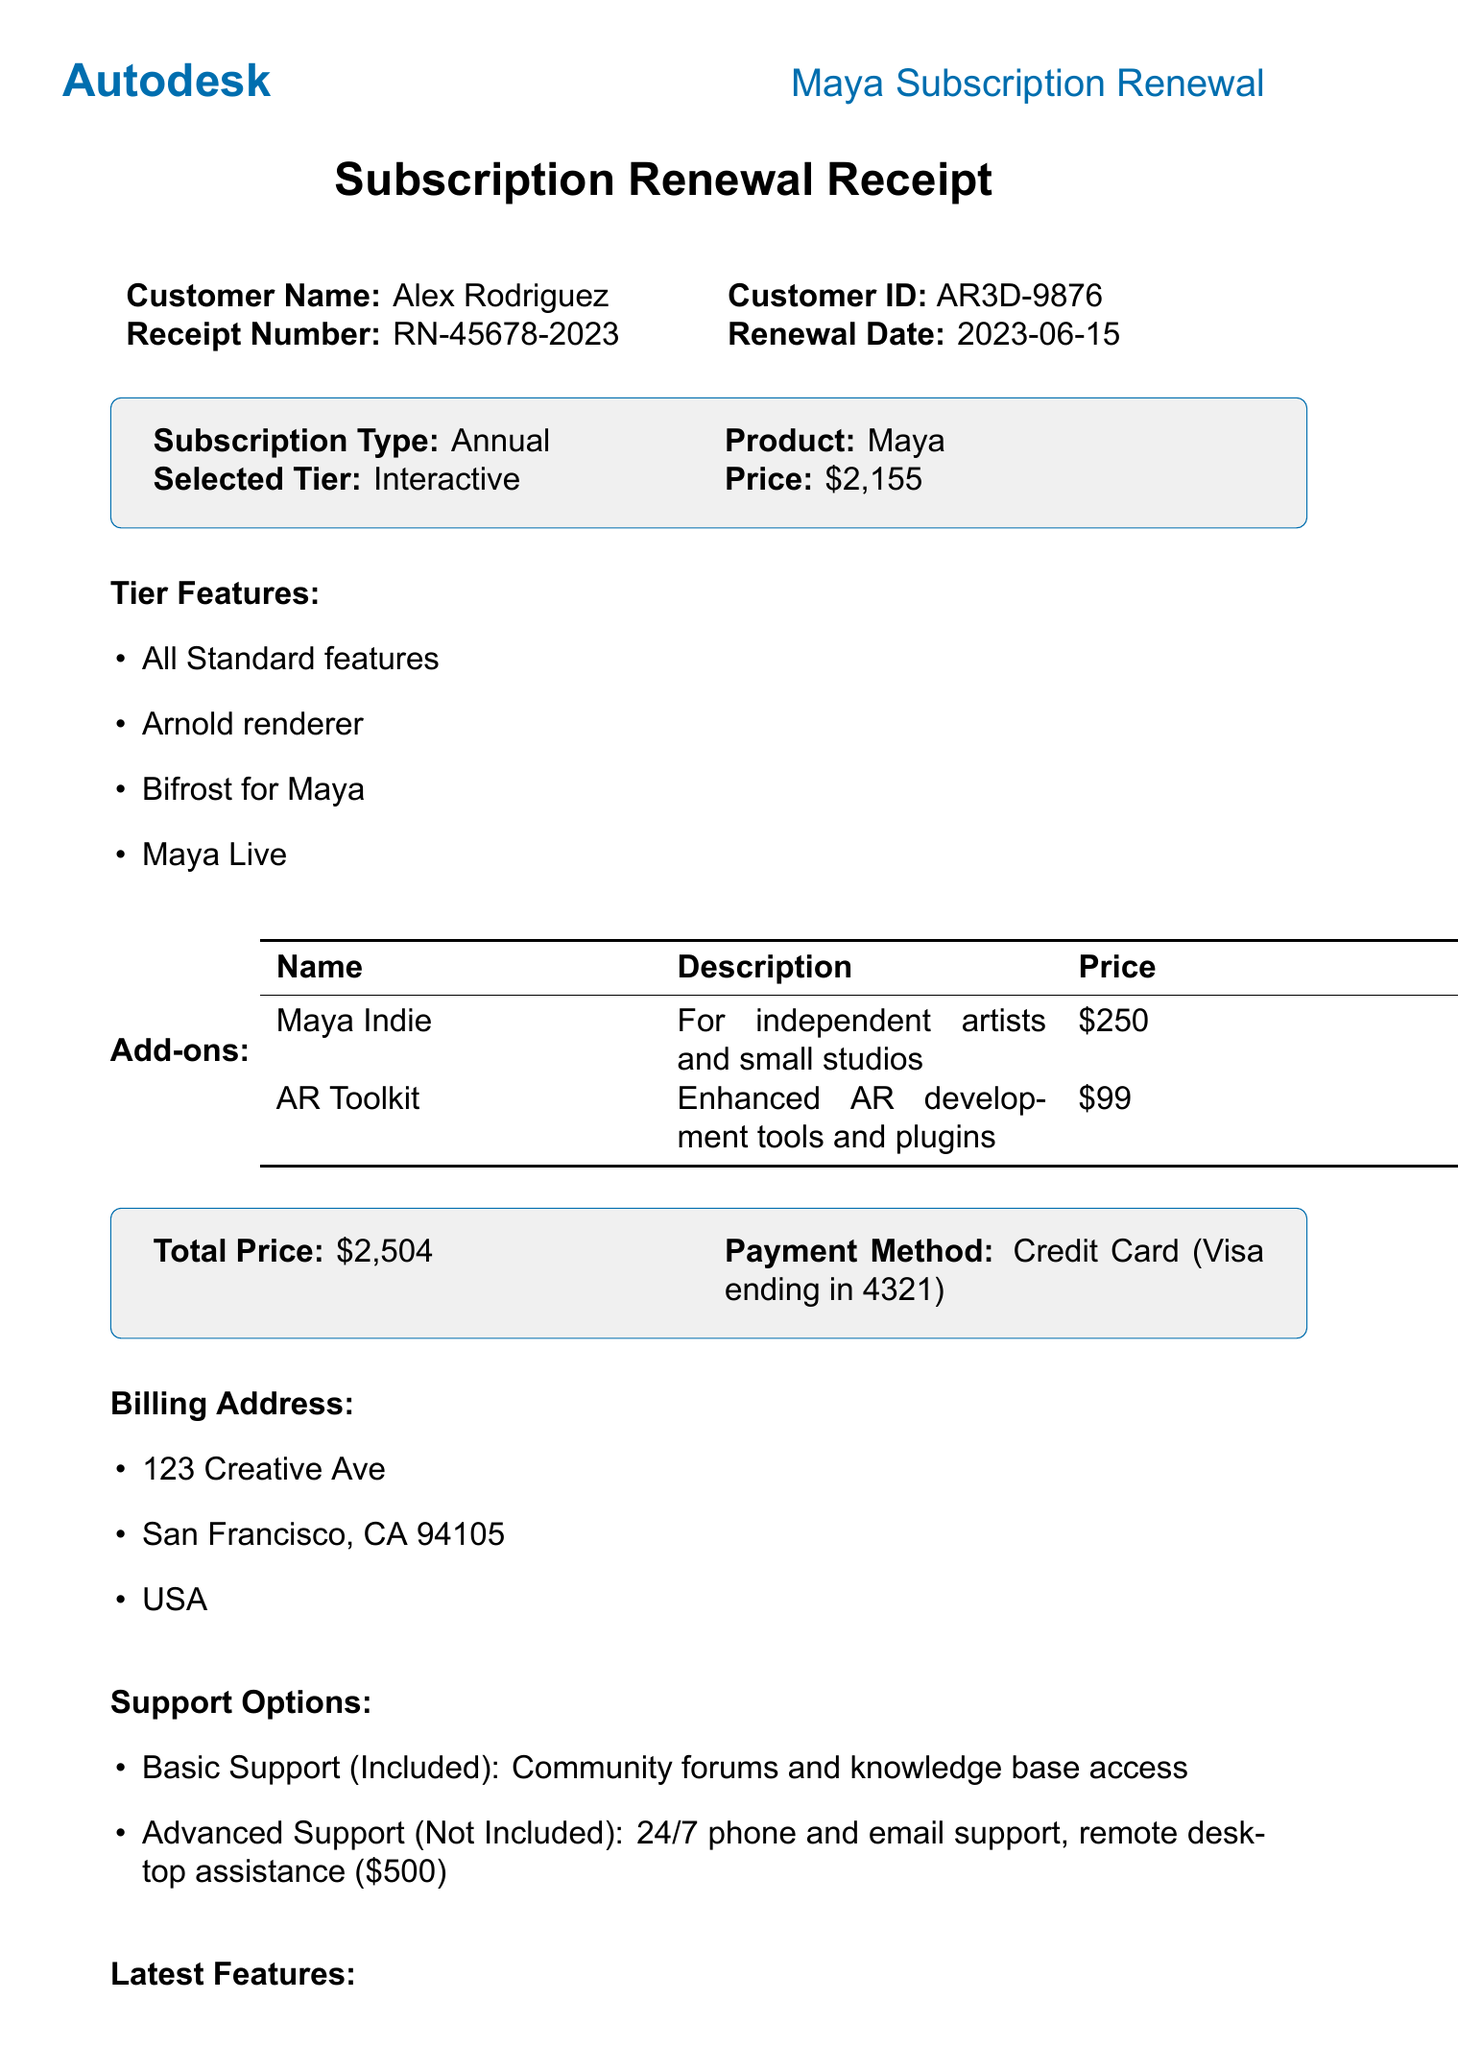What is the name of the product? The name of the product is listed in the document as "Maya."
Answer: Maya What is the renewal date? The renewal date is specified in the document as June 15, 2023.
Answer: 2023-06-15 What is the total price? The total price is detailed in the document as $2,504.
Answer: $2,504 What discount was applied? The document states a "Loyal Customer Discount" of 5% was applied.
Answer: Loyal Customer Discount How much was saved due to the discount? The amount saved due to the discount is noted as $107.75 in the document.
Answer: $107.75 What are the features of the Interactive tier? The features detail the capabilities of the Interactive tier, which are all Standard features, Arnold renderer, Bifrost for Maya, and Maya Live.
Answer: All Standard features, Arnold renderer, Bifrost for Maya, Maya Live What is the payment method? The payment method used is indicated in the document as "Credit Card (Visa ending in 4321)."
Answer: Credit Card (Visa ending in 4321) Is Advanced Support included? The document specifies that Advanced Support is not included, requiring a separate payment.
Answer: No What is the cancellation policy? The cancellation policy states that a 30-day notice is required for cancellation.
Answer: 30-day notice required 